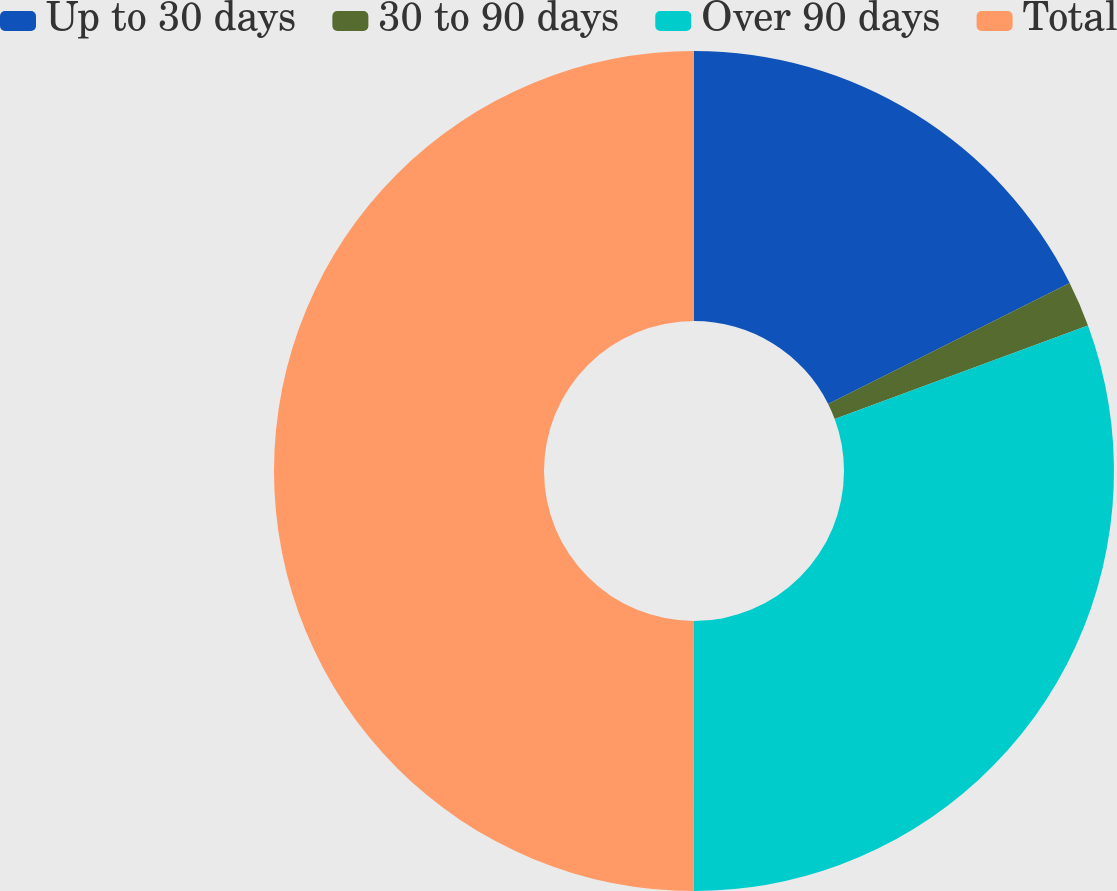Convert chart to OTSL. <chart><loc_0><loc_0><loc_500><loc_500><pie_chart><fcel>Up to 30 days<fcel>30 to 90 days<fcel>Over 90 days<fcel>Total<nl><fcel>17.62%<fcel>1.75%<fcel>30.64%<fcel>50.0%<nl></chart> 